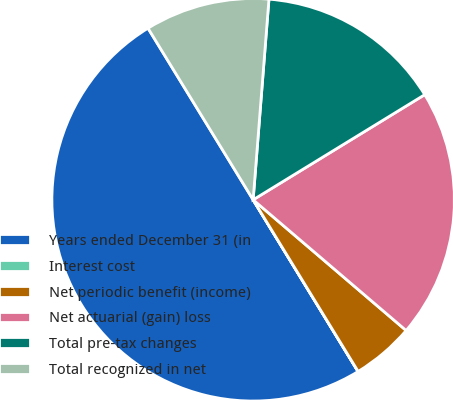<chart> <loc_0><loc_0><loc_500><loc_500><pie_chart><fcel>Years ended December 31 (in<fcel>Interest cost<fcel>Net periodic benefit (income)<fcel>Net actuarial (gain) loss<fcel>Total pre-tax changes<fcel>Total recognized in net<nl><fcel>49.98%<fcel>0.01%<fcel>5.01%<fcel>20.0%<fcel>15.0%<fcel>10.0%<nl></chart> 